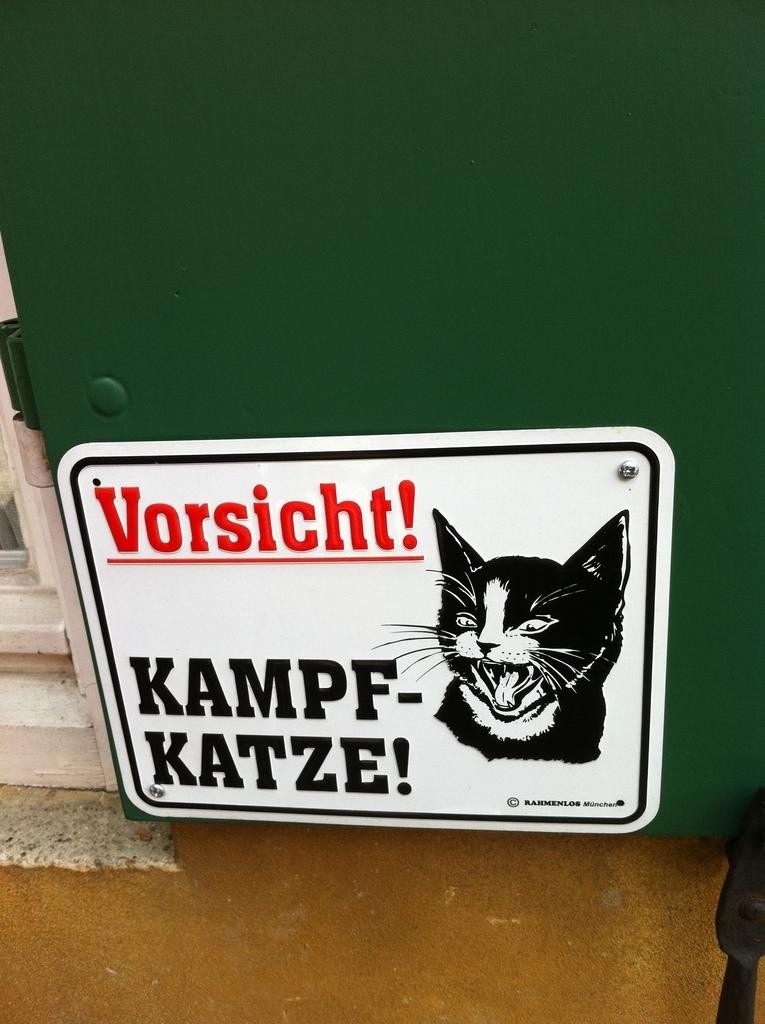What type of cartoon is depicted in the image? There is a cats cartoon in the image. What material is the plate made of in the image? The plate in the image is made of white color steel. Where is the door located in the image? The door is on the left side of the image. What surface can be seen beneath the cartoon and plate in the image? There is a floor visible in the image. Can you tell me how much lettuce is on the scale in the image? There is no lettuce or scale present in the image. 